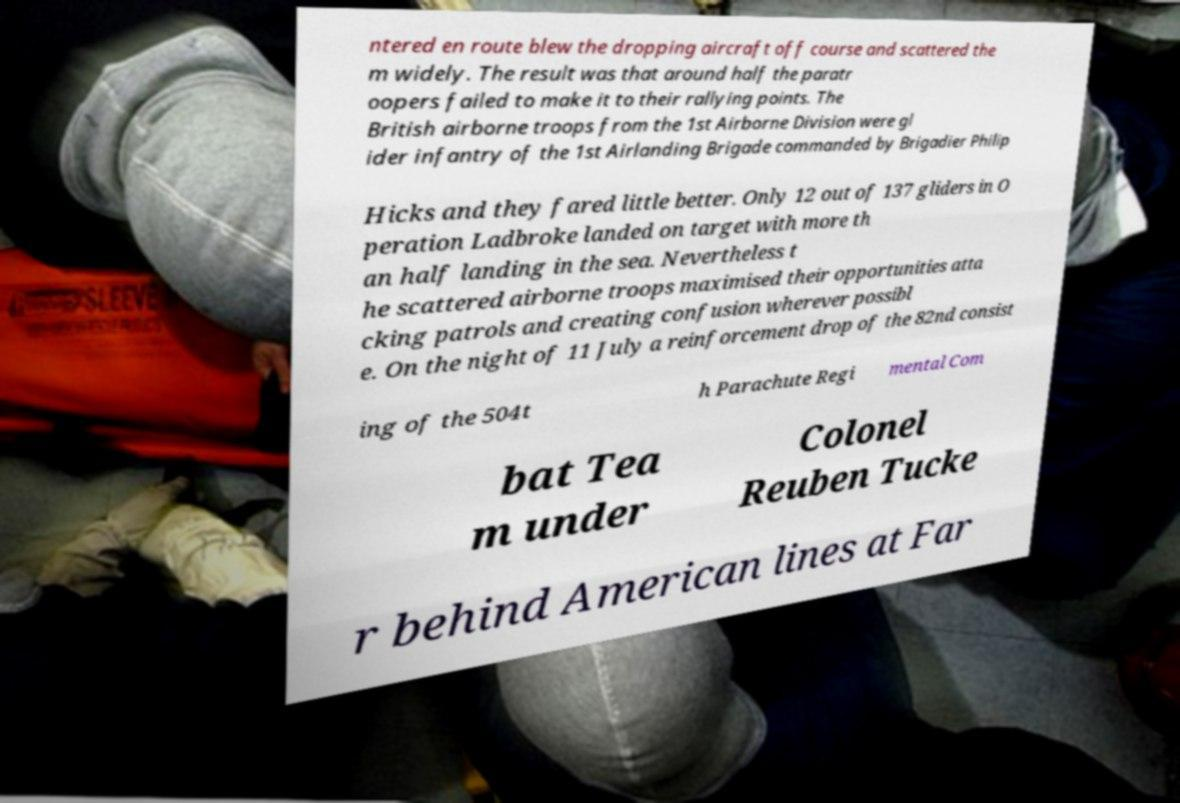Could you assist in decoding the text presented in this image and type it out clearly? ntered en route blew the dropping aircraft off course and scattered the m widely. The result was that around half the paratr oopers failed to make it to their rallying points. The British airborne troops from the 1st Airborne Division were gl ider infantry of the 1st Airlanding Brigade commanded by Brigadier Philip Hicks and they fared little better. Only 12 out of 137 gliders in O peration Ladbroke landed on target with more th an half landing in the sea. Nevertheless t he scattered airborne troops maximised their opportunities atta cking patrols and creating confusion wherever possibl e. On the night of 11 July a reinforcement drop of the 82nd consist ing of the 504t h Parachute Regi mental Com bat Tea m under Colonel Reuben Tucke r behind American lines at Far 